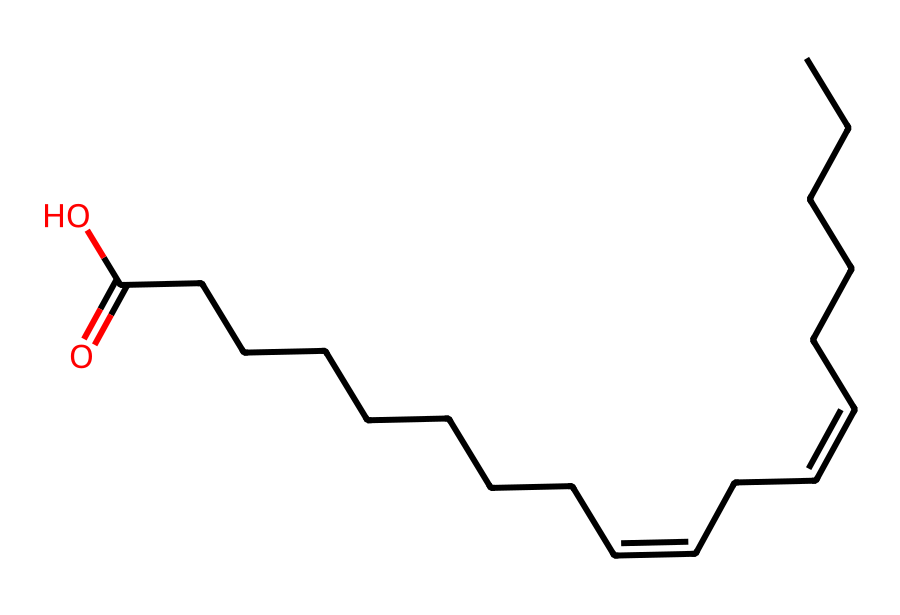What is the total number of carbon atoms in this chemical? By analyzing the SMILES representation, we can count the carbon atoms indicated by each 'C' in the structure. The structure shows a combination of linear and branched carbon chains, and careful counting reveals a total of 18 carbon atoms.
Answer: 18 How many double bonds are present in this molecule? The SMILES shows two instances of "/C=C\", which indicates the presence of double bonds between carbon atoms. Counting these representations gives us a total of 2 double bonds in the molecule.
Answer: 2 What functional group is present in this chemical? The presence of the "CCCCCCCC(=O)O" section indicates a carboxylic acid functional group, with the -COOH structure at the end of the carbon chain.
Answer: carboxylic acid Is this molecule a saturated or unsaturated lipid? The presence of double bonds suggests that the molecule has less than the maximum number of hydrogen atoms attached to the carbon chain, which qualifies it as an unsaturated lipid.
Answer: unsaturated What type of lipid does this molecule represent? Given the structure’s appearance and the presence of multiple double bonds, it is identified as a fatty acid, which is a class of lipids.
Answer: fatty acid How many hydrogen atoms can be deduced from the structure of this molecule? Each carbon atom typically bonds with a maximum of four atoms total, considering the existing double bonds. By calculating the hydrogens that fill the remaining bonding sites across all carbon atoms (18 carbons and 2 double bonds), it yields a total of 32 hydrogen atoms.
Answer: 32 